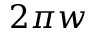Convert formula to latex. <formula><loc_0><loc_0><loc_500><loc_500>2 \pi w</formula> 